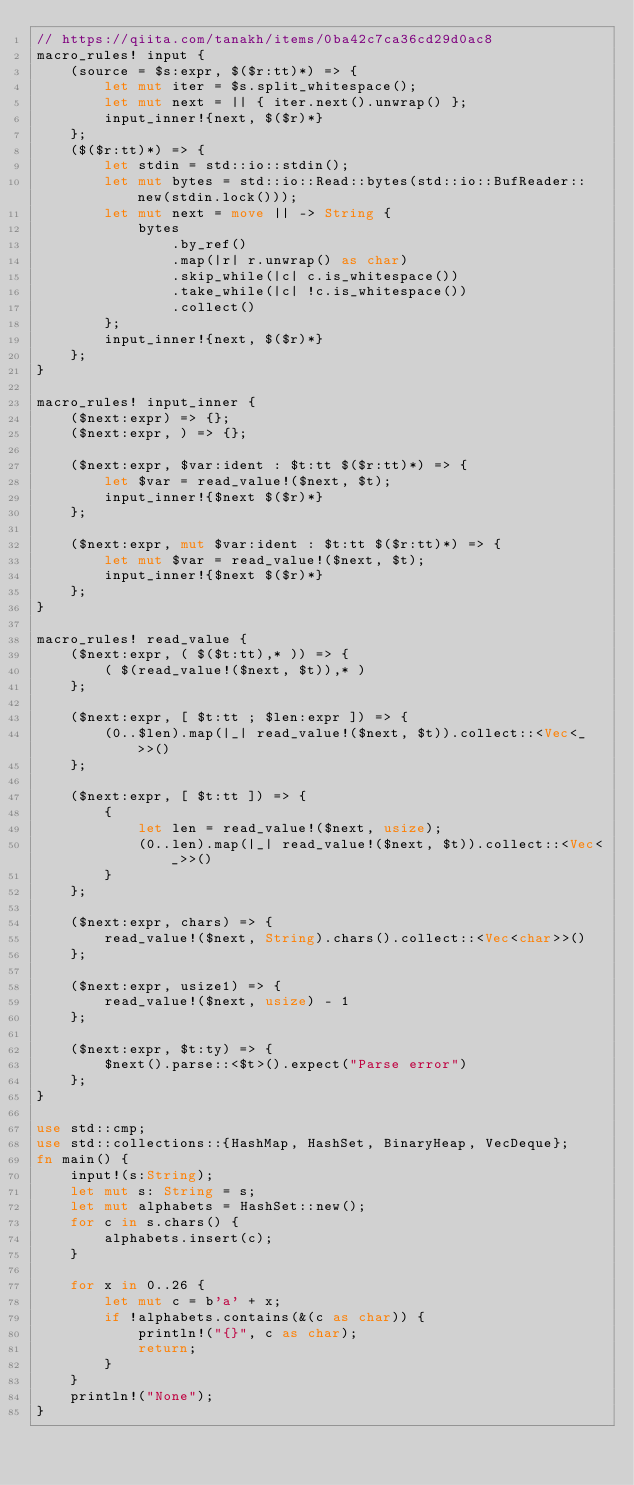Convert code to text. <code><loc_0><loc_0><loc_500><loc_500><_Rust_>// https://qiita.com/tanakh/items/0ba42c7ca36cd29d0ac8
macro_rules! input {
    (source = $s:expr, $($r:tt)*) => {
        let mut iter = $s.split_whitespace();
        let mut next = || { iter.next().unwrap() };
        input_inner!{next, $($r)*}
    };
    ($($r:tt)*) => {
        let stdin = std::io::stdin();
        let mut bytes = std::io::Read::bytes(std::io::BufReader::new(stdin.lock()));
        let mut next = move || -> String {
            bytes
                .by_ref()
                .map(|r| r.unwrap() as char)
                .skip_while(|c| c.is_whitespace())
                .take_while(|c| !c.is_whitespace())
                .collect()
        };
        input_inner!{next, $($r)*}
    };
}

macro_rules! input_inner {
    ($next:expr) => {};
    ($next:expr, ) => {};

    ($next:expr, $var:ident : $t:tt $($r:tt)*) => {
        let $var = read_value!($next, $t);
        input_inner!{$next $($r)*}
    };

    ($next:expr, mut $var:ident : $t:tt $($r:tt)*) => {
        let mut $var = read_value!($next, $t);
        input_inner!{$next $($r)*}
    };
}

macro_rules! read_value {
    ($next:expr, ( $($t:tt),* )) => {
        ( $(read_value!($next, $t)),* )
    };

    ($next:expr, [ $t:tt ; $len:expr ]) => {
        (0..$len).map(|_| read_value!($next, $t)).collect::<Vec<_>>()
    };

    ($next:expr, [ $t:tt ]) => {
        {
            let len = read_value!($next, usize);
            (0..len).map(|_| read_value!($next, $t)).collect::<Vec<_>>()
        }
    };

    ($next:expr, chars) => {
        read_value!($next, String).chars().collect::<Vec<char>>()
    };

    ($next:expr, usize1) => {
        read_value!($next, usize) - 1
    };

    ($next:expr, $t:ty) => {
        $next().parse::<$t>().expect("Parse error")
    };
}

use std::cmp;
use std::collections::{HashMap, HashSet, BinaryHeap, VecDeque};
fn main() {
    input!(s:String);
    let mut s: String = s;
    let mut alphabets = HashSet::new();
    for c in s.chars() {
        alphabets.insert(c);
    }
    
    for x in 0..26 {
        let mut c = b'a' + x;
        if !alphabets.contains(&(c as char)) {
            println!("{}", c as char);
            return;
        }
    }
    println!("None");
}
</code> 